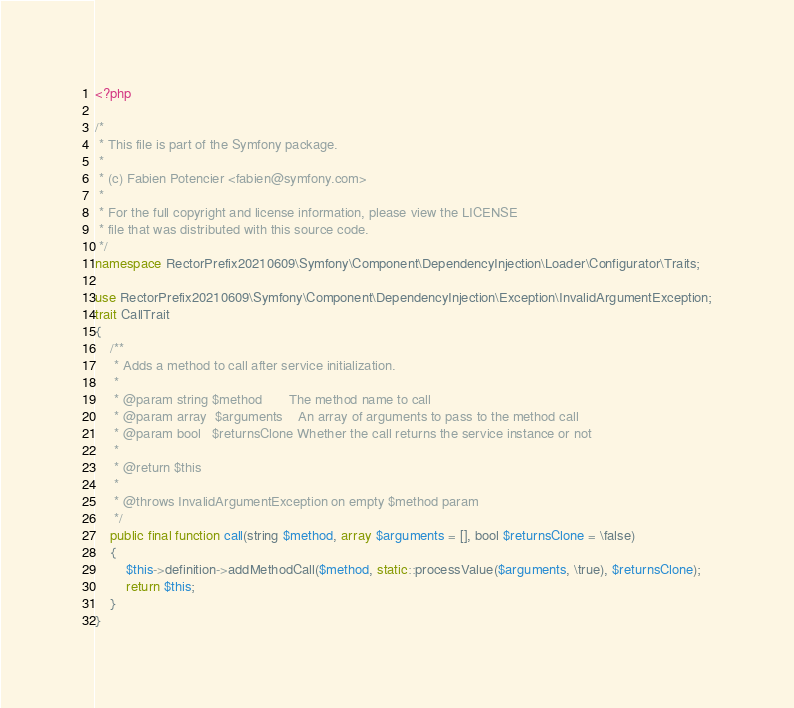Convert code to text. <code><loc_0><loc_0><loc_500><loc_500><_PHP_><?php

/*
 * This file is part of the Symfony package.
 *
 * (c) Fabien Potencier <fabien@symfony.com>
 *
 * For the full copyright and license information, please view the LICENSE
 * file that was distributed with this source code.
 */
namespace RectorPrefix20210609\Symfony\Component\DependencyInjection\Loader\Configurator\Traits;

use RectorPrefix20210609\Symfony\Component\DependencyInjection\Exception\InvalidArgumentException;
trait CallTrait
{
    /**
     * Adds a method to call after service initialization.
     *
     * @param string $method       The method name to call
     * @param array  $arguments    An array of arguments to pass to the method call
     * @param bool   $returnsClone Whether the call returns the service instance or not
     *
     * @return $this
     *
     * @throws InvalidArgumentException on empty $method param
     */
    public final function call(string $method, array $arguments = [], bool $returnsClone = \false)
    {
        $this->definition->addMethodCall($method, static::processValue($arguments, \true), $returnsClone);
        return $this;
    }
}
</code> 